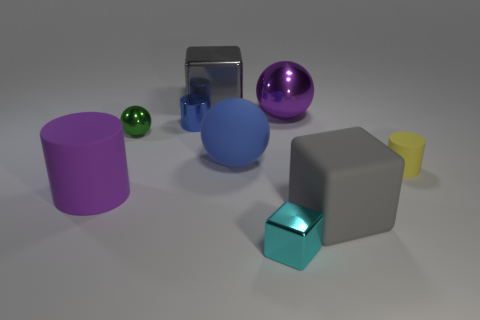Add 1 large gray metallic objects. How many objects exist? 10 Subtract all blocks. How many objects are left? 6 Subtract 0 green cylinders. How many objects are left? 9 Subtract all purple balls. Subtract all big purple shiny things. How many objects are left? 7 Add 4 big purple shiny things. How many big purple shiny things are left? 5 Add 7 tiny blue cylinders. How many tiny blue cylinders exist? 8 